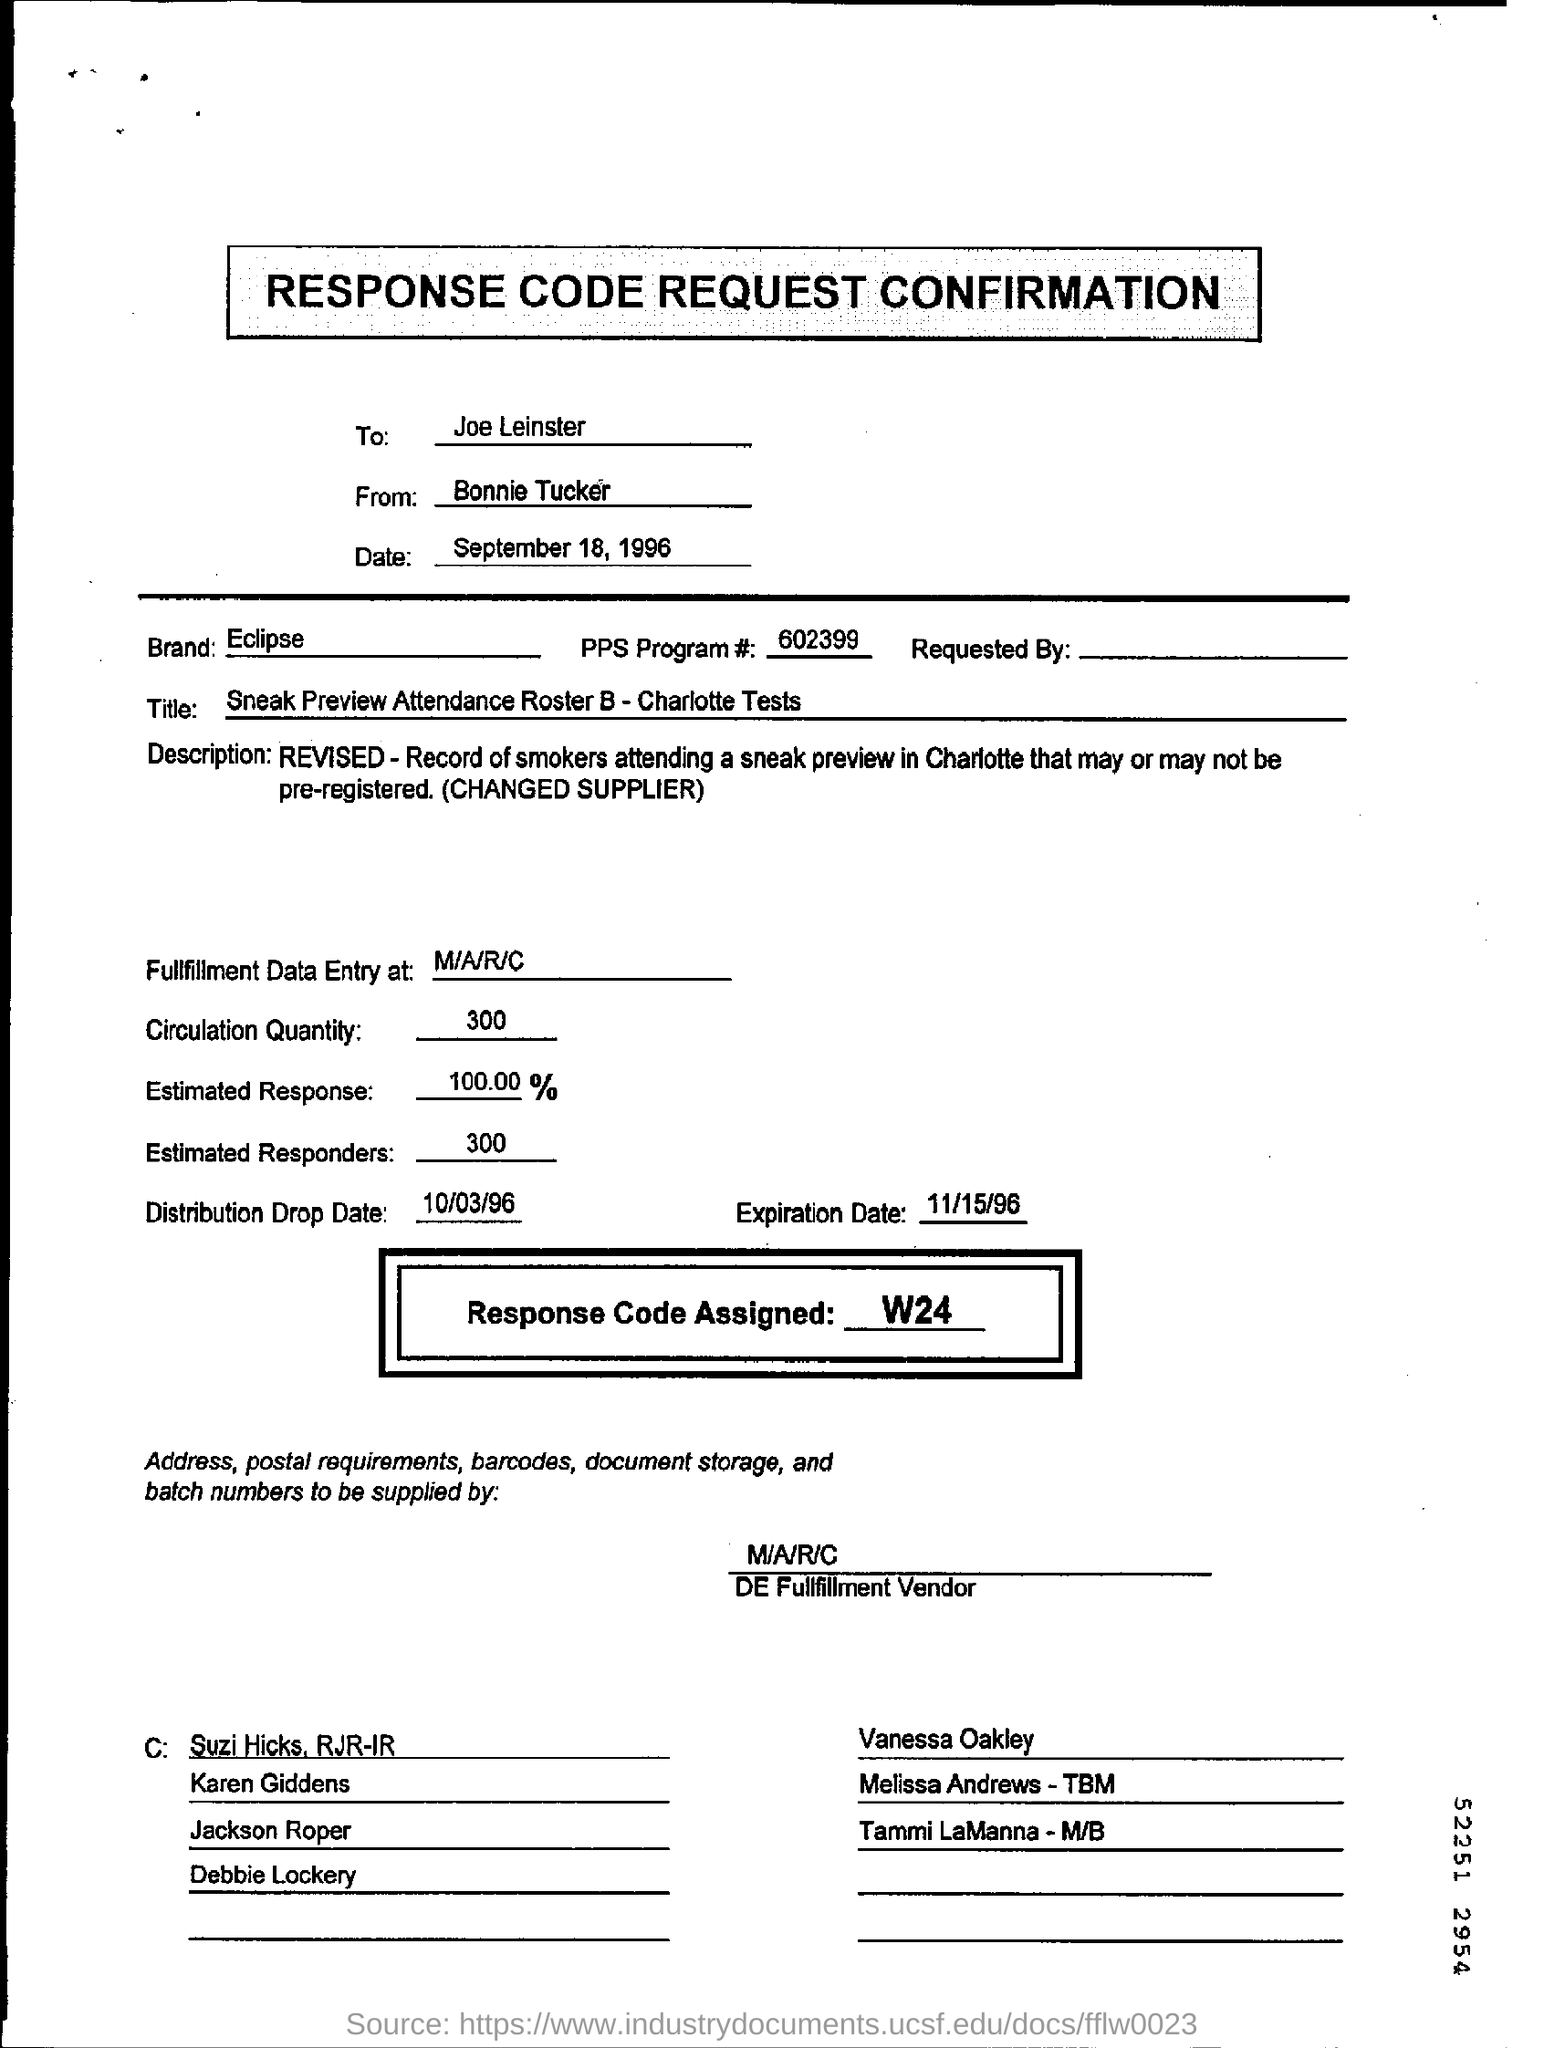Identify some key points in this picture. The date mentioned in the form is September 18, 1996. The estimated response is 100.00. The PPS program number is 602399... The circulation quantity mentioned is 300. 